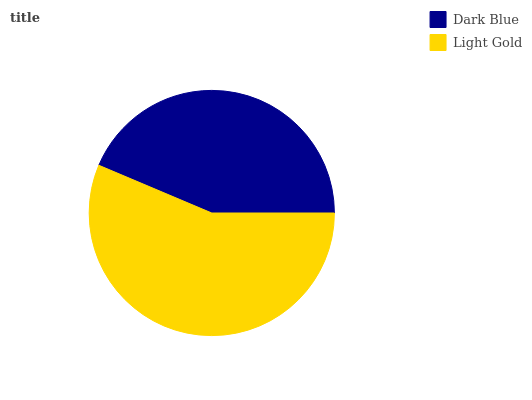Is Dark Blue the minimum?
Answer yes or no. Yes. Is Light Gold the maximum?
Answer yes or no. Yes. Is Light Gold the minimum?
Answer yes or no. No. Is Light Gold greater than Dark Blue?
Answer yes or no. Yes. Is Dark Blue less than Light Gold?
Answer yes or no. Yes. Is Dark Blue greater than Light Gold?
Answer yes or no. No. Is Light Gold less than Dark Blue?
Answer yes or no. No. Is Light Gold the high median?
Answer yes or no. Yes. Is Dark Blue the low median?
Answer yes or no. Yes. Is Dark Blue the high median?
Answer yes or no. No. Is Light Gold the low median?
Answer yes or no. No. 